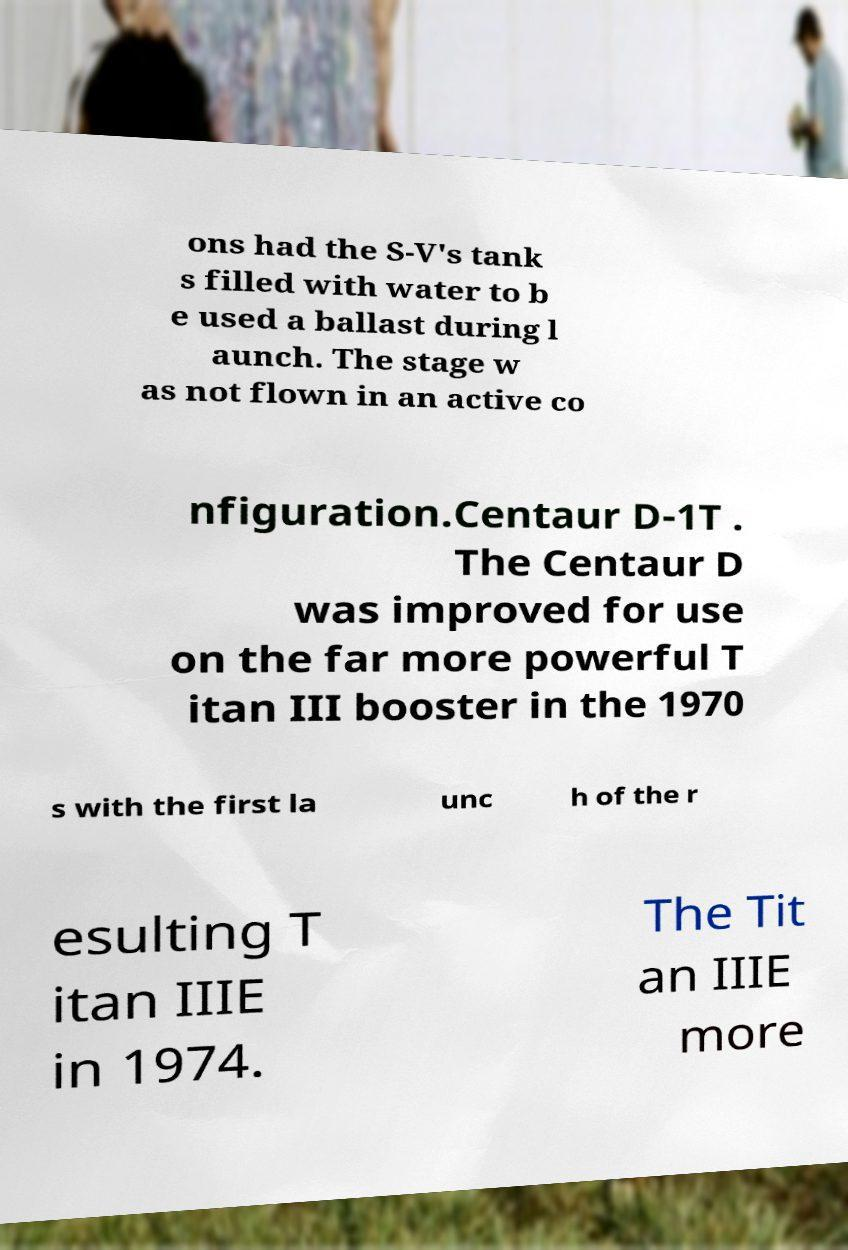There's text embedded in this image that I need extracted. Can you transcribe it verbatim? ons had the S-V's tank s filled with water to b e used a ballast during l aunch. The stage w as not flown in an active co nfiguration.Centaur D-1T . The Centaur D was improved for use on the far more powerful T itan III booster in the 1970 s with the first la unc h of the r esulting T itan IIIE in 1974. The Tit an IIIE more 